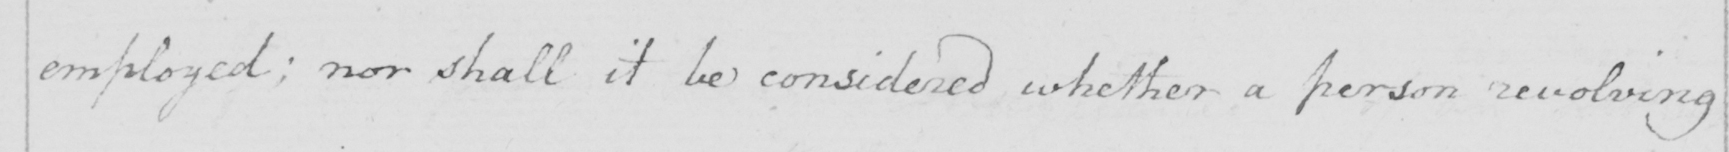Can you tell me what this handwritten text says? employed; nor shall it be considered whether a person revolving 